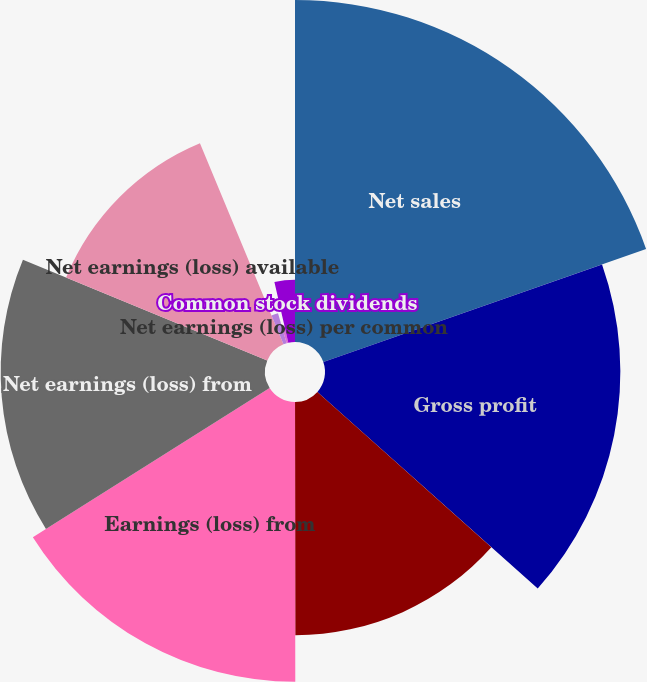Convert chart. <chart><loc_0><loc_0><loc_500><loc_500><pie_chart><fcel>Net sales<fcel>Gross profit<fcel>Operating profit (loss)<fcel>Earnings (loss) from<fcel>Net earnings (loss) from<fcel>Net earnings (loss) available<fcel>Continuing operations<fcel>Net earnings (loss) per common<fcel>Common stock dividends<nl><fcel>19.64%<fcel>16.96%<fcel>13.39%<fcel>16.07%<fcel>15.18%<fcel>12.5%<fcel>1.79%<fcel>0.9%<fcel>3.58%<nl></chart> 